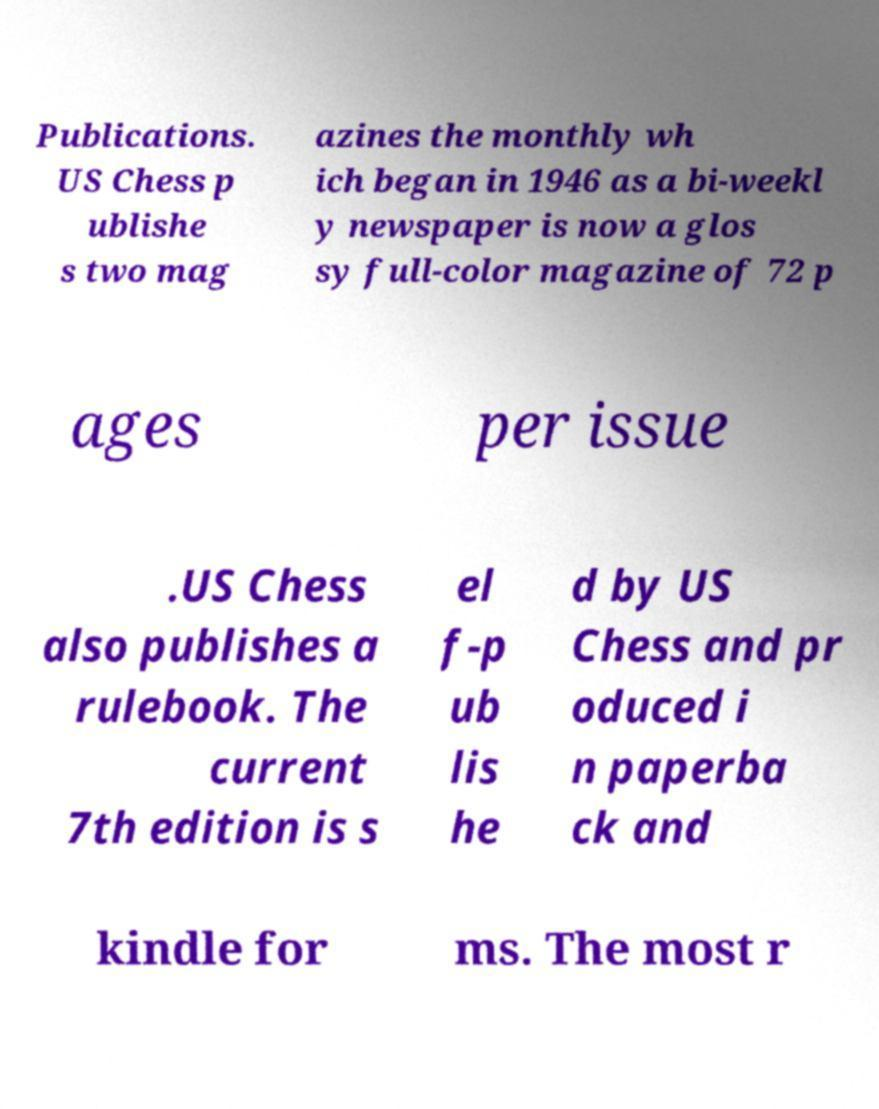I need the written content from this picture converted into text. Can you do that? Publications. US Chess p ublishe s two mag azines the monthly wh ich began in 1946 as a bi-weekl y newspaper is now a glos sy full-color magazine of 72 p ages per issue .US Chess also publishes a rulebook. The current 7th edition is s el f-p ub lis he d by US Chess and pr oduced i n paperba ck and kindle for ms. The most r 